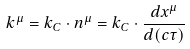Convert formula to latex. <formula><loc_0><loc_0><loc_500><loc_500>k ^ { \mu } = k _ { C } \cdot n ^ { \mu } = k _ { C } \cdot \frac { d x ^ { \mu } } { d ( c \tau ) }</formula> 